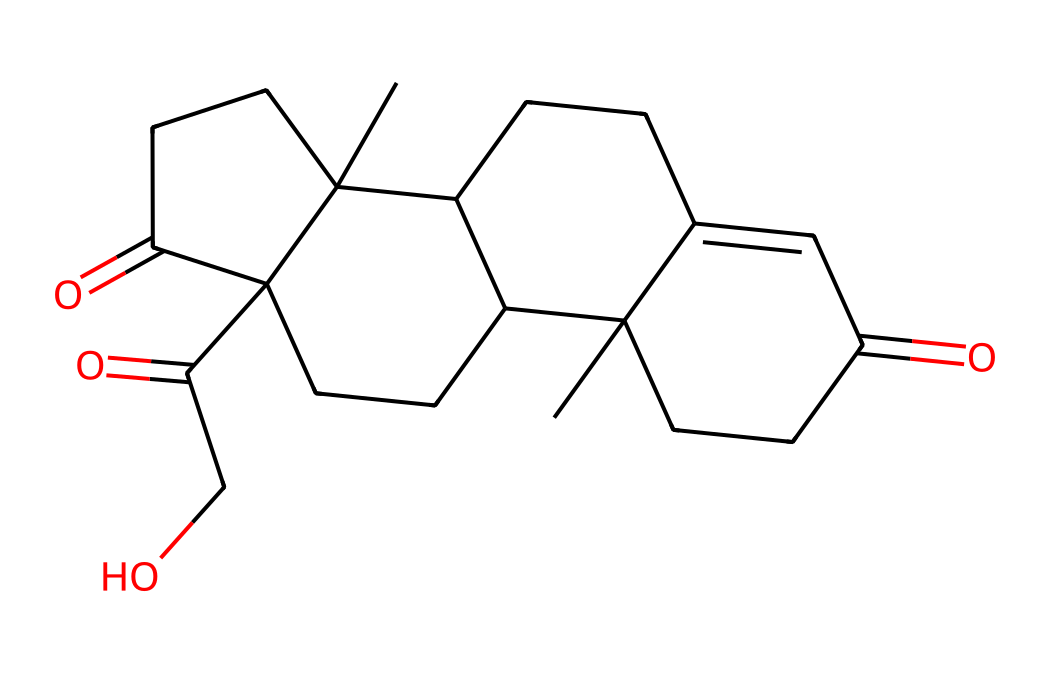What is the molecular formula of cortisol? To determine the molecular formula, count the number of carbon (C), hydrogen (H), and oxygen (O) atoms in the SMILES representation. The breakdown is: 21 carbon atoms, 30 hydrogen atoms, and 5 oxygen atoms. Therefore, the molecular formula is C21H30O5.
Answer: C21H30O5 How many rings are present in the cortisol structure? By analyzing the SMILES representation, identify the sections that indicate cyclic structures, specifically the numeric indicators (1, 2, 3, 4) which denote ring formations. There are four rings in the cortisol structure as indicated by these numbers.
Answer: 4 What functional groups are present in cortisol? Examine the SMILES for specific patterns: the ketone groups (C=O) and hydroxyl groups (C-OH). The presence of these groups indicates that cortisol has three ketone functional groups and one hydroxyl functional group.
Answer: ketone and hydroxyl What does cortisol primarily regulate in the body? Based on the known biological role of cortisol, it primarily regulates stress response and metabolism, influencing multiple physiological processes. Thus, the primary regulation associated with cortisol is stress management.
Answer: stress management What impact does cortisol have on energy levels during concerts? Cortisol is involved in the metabolism of glucose and can increase glucose availability, which provides energy for prolonged physical activity, such as during concerts. Therefore, cortisol helps sustain energy levels.
Answer: energy levels How does cortisol help in managing stress? Cortisol responds to stress by enhancing the body's metabolism, particularly by increasing blood sugar levels and modulating other hormones, which facilitates the energy needed to cope with stress. This plays a crucial role in stress management.
Answer: stress management 